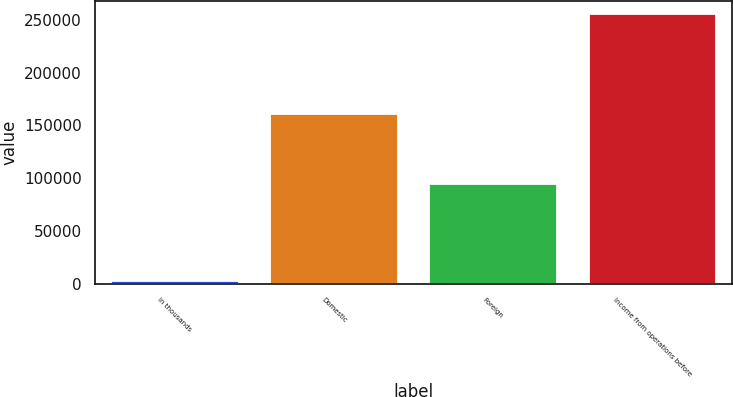Convert chart. <chart><loc_0><loc_0><loc_500><loc_500><bar_chart><fcel>In thousands<fcel>Domestic<fcel>Foreign<fcel>Income from operations before<nl><fcel>2011<fcel>161108<fcel>94206<fcel>255314<nl></chart> 